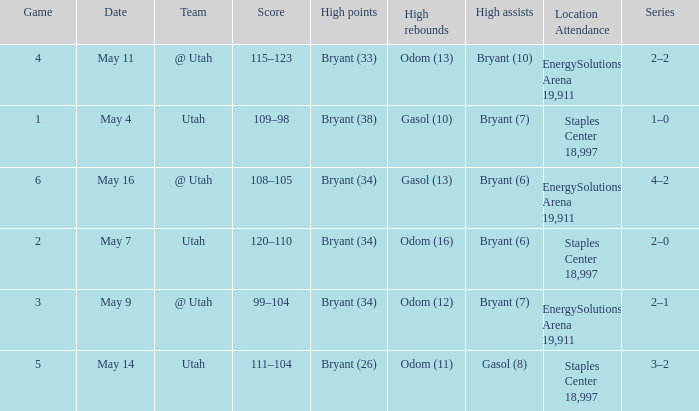Could you help me parse every detail presented in this table? {'header': ['Game', 'Date', 'Team', 'Score', 'High points', 'High rebounds', 'High assists', 'Location Attendance', 'Series'], 'rows': [['4', 'May 11', '@ Utah', '115–123', 'Bryant (33)', 'Odom (13)', 'Bryant (10)', 'EnergySolutions Arena 19,911', '2–2'], ['1', 'May 4', 'Utah', '109–98', 'Bryant (38)', 'Gasol (10)', 'Bryant (7)', 'Staples Center 18,997', '1–0'], ['6', 'May 16', '@ Utah', '108–105', 'Bryant (34)', 'Gasol (13)', 'Bryant (6)', 'EnergySolutions Arena 19,911', '4–2'], ['2', 'May 7', 'Utah', '120–110', 'Bryant (34)', 'Odom (16)', 'Bryant (6)', 'Staples Center 18,997', '2–0'], ['3', 'May 9', '@ Utah', '99–104', 'Bryant (34)', 'Odom (12)', 'Bryant (7)', 'EnergySolutions Arena 19,911', '2–1'], ['5', 'May 14', 'Utah', '111–104', 'Bryant (26)', 'Odom (11)', 'Gasol (8)', 'Staples Center 18,997', '3–2']]} What is the High rebounds with a High assists with bryant (7), and a Team of @ utah? Odom (12). 